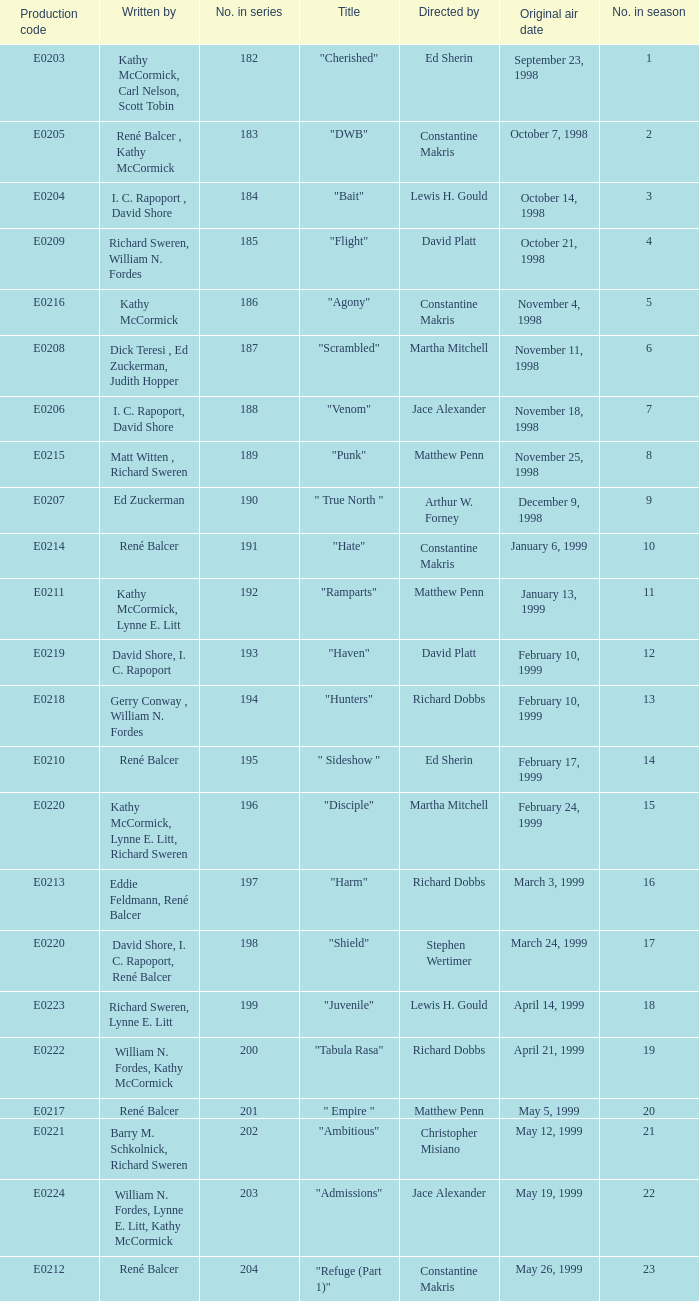The episode with the original air date January 6, 1999, has what production code? E0214. 